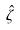<formula> <loc_0><loc_0><loc_500><loc_500>\hat { \zeta }</formula> 